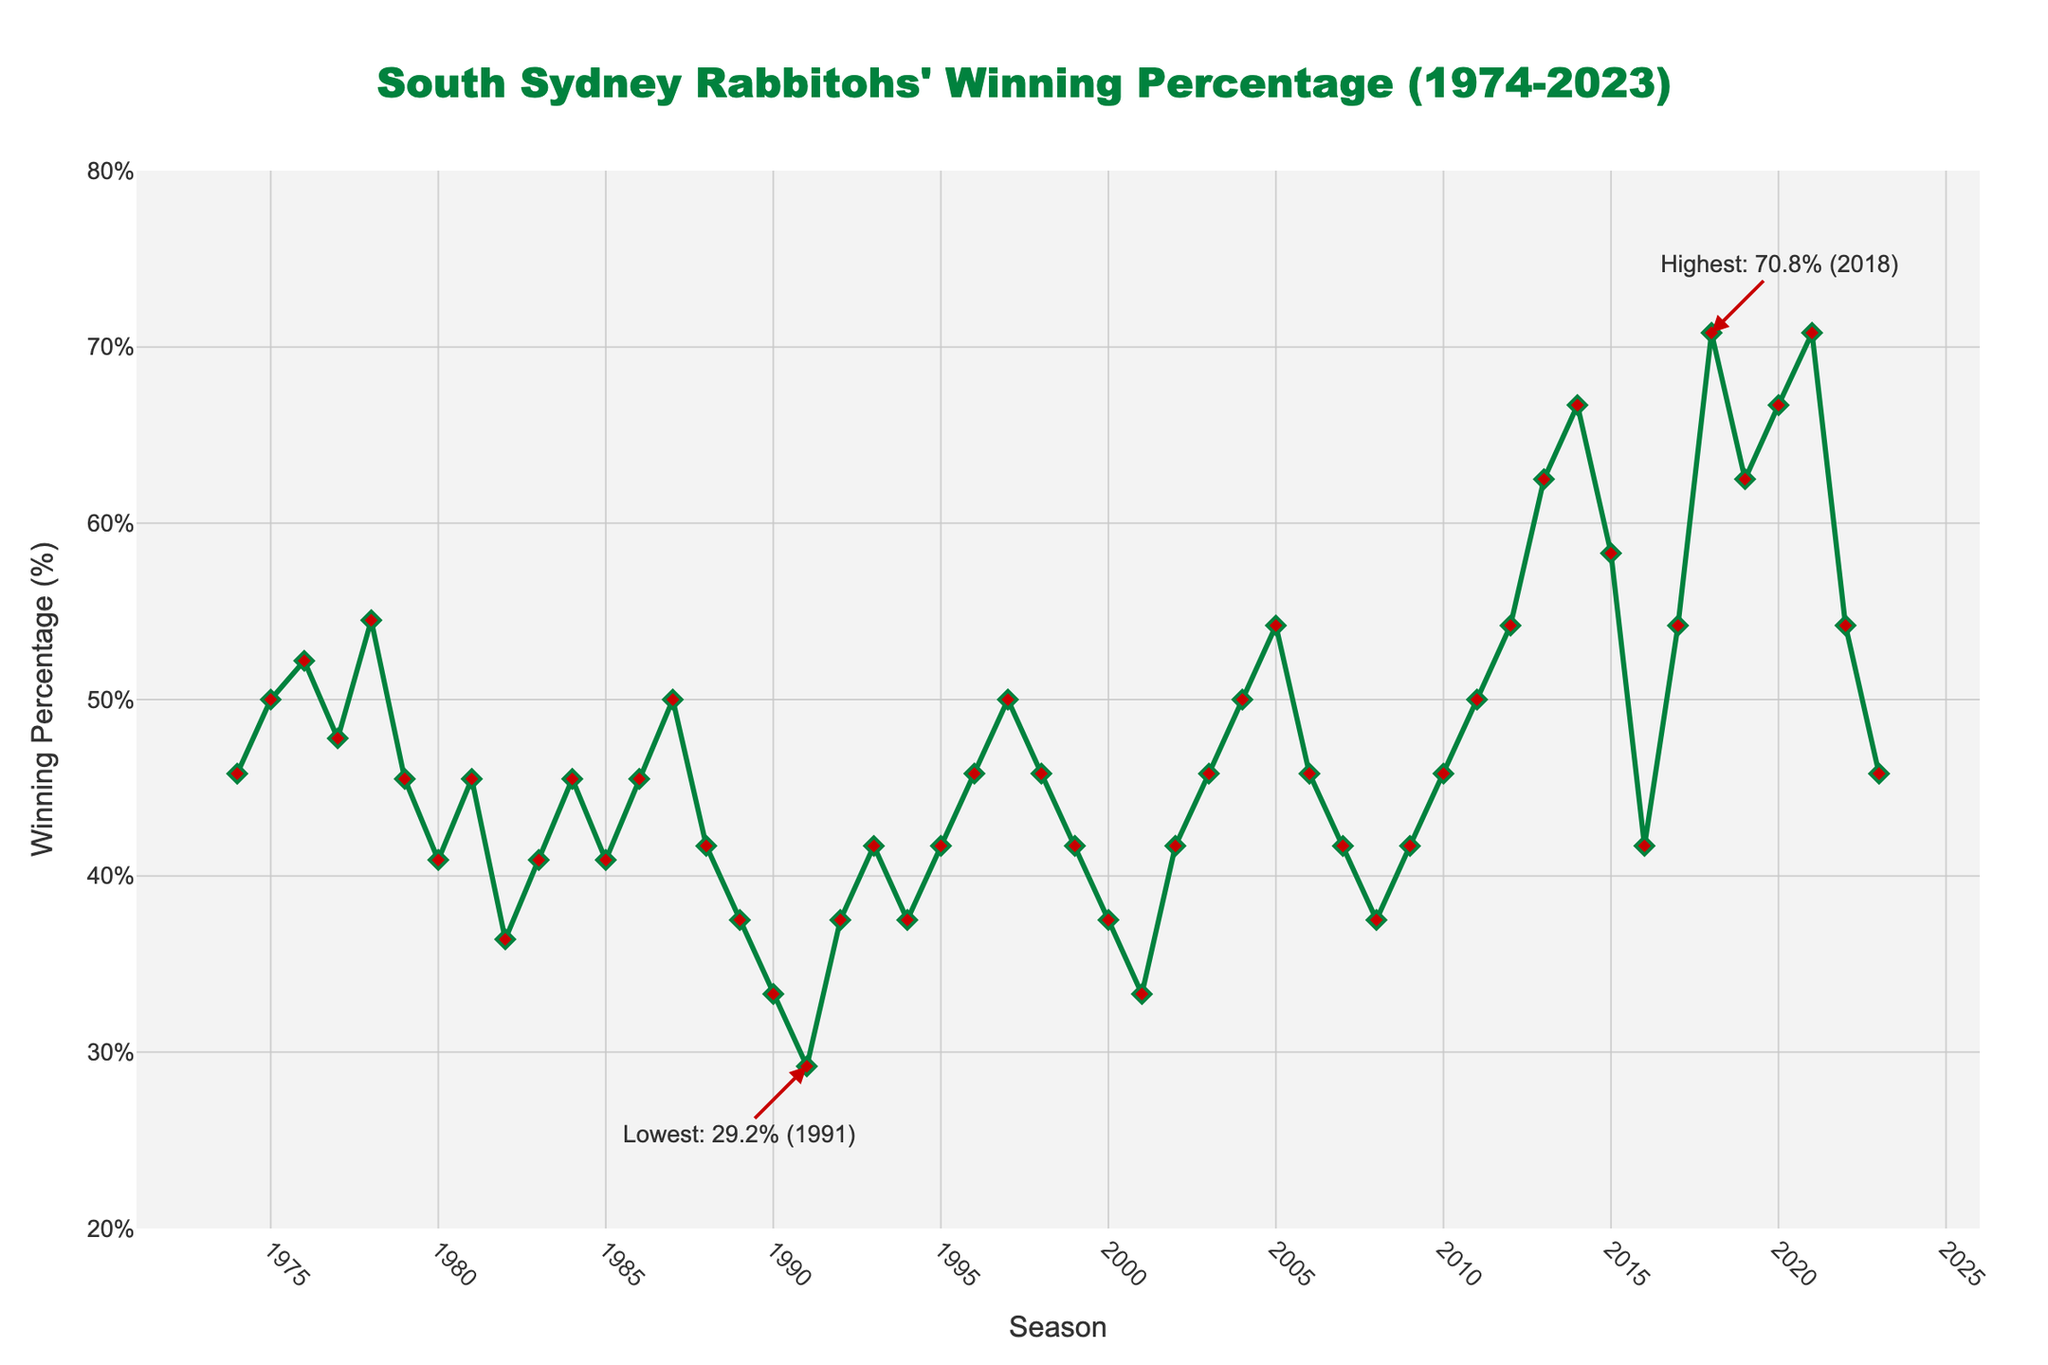What's the highest winning percentage recorded by the Rabbitohs, and in which season did it occur? The annotation on the figure shows the highest point. The annotation indicates that the highest winning percentage was 70.8% and occurred in 2018 and 2021.
Answer: 70.8%, 2018 and 2021 What is the lowest winning percentage recorded by the Rabbitohs, and in which season did it occur? The annotation on the figure shows the lowest point. The annotation indicates that the lowest winning percentage was 29.2% and occurred in 1991.
Answer: 29.2%, 1991 How did the winning percentage change from 1988 to 1992? The figure shows a downward trend from 1988 (41.7%) to 1991 (29.2%), followed by an increase in 1992 (37.5%). Calculate the differences: from 1988 to 1991, the decrease is 41.7% - 29.2% = 12.5%, and from 1991 to 1992, the increase is 37.5% - 29.2% = 8.3%.
Answer: Decreased by 12.5% then increased by 8.3% What is the difference in the winning percentage between 2005 and 2010? From the figure, the winning percentage in 2005 was 54.2%, and in 2010 it was 45.8%. The difference is 54.2% - 45.8%.
Answer: 8.4% During which decade did the Rabbitohs experience the most significant improvement in their winning percentage? By visually inspecting the slopes for each decade on the figure, the most significant upward trend appears to be from 2010 to 2020, where the percentage climbed from 45.8% to 70.8%.
Answer: 2010 to 2020 Compare the winning percentages of the 1974 season and the 2023 season. Which one is higher, and by how much? From the figure, the winning percentage in 1974 was 45.8%, and in 2023, it was still 45.8%. Therefore, the winning percentages are equal.
Answer: Equal, 0% What was the average winning percentage for the 1980s? The data for the seasons 1980 to 1989 are: 40.9%, 45.5%, 36.4%, 40.9%, 45.5%, 40.9%, 45.5%, 50.0%, 41.7%, 37.5%. Sum these values and divide by the number of seasons (10): (40.9 + 45.5 + 36.4 + 40.9 + 45.5 + 40.9 + 45.5 + 50.0 + 41.7 + 37.5) / 10 = 42.48%.
Answer: 42.5% How does the winning percentage in 2003 compare to that of 2004? From the figure, the winning percentage in 2003 was 45.8%, and in 2004 it was 50.0%. The percentage in 2004 is higher than in 2003 by 50.0% - 45.8% = 4.2%.
Answer: Increased by 4.2% What was the winning percentage trend between 2014 and 2016? According to the figure, the winning percentage in 2014 was 66.7%, in 2015 it was 58.3%, and in 2016 it was 41.7%. There was a continuous decrease each year with a total decrease: 66.7% - 41.7% = 25%.
Answer: Decreasing trend, total decrease of 25% 